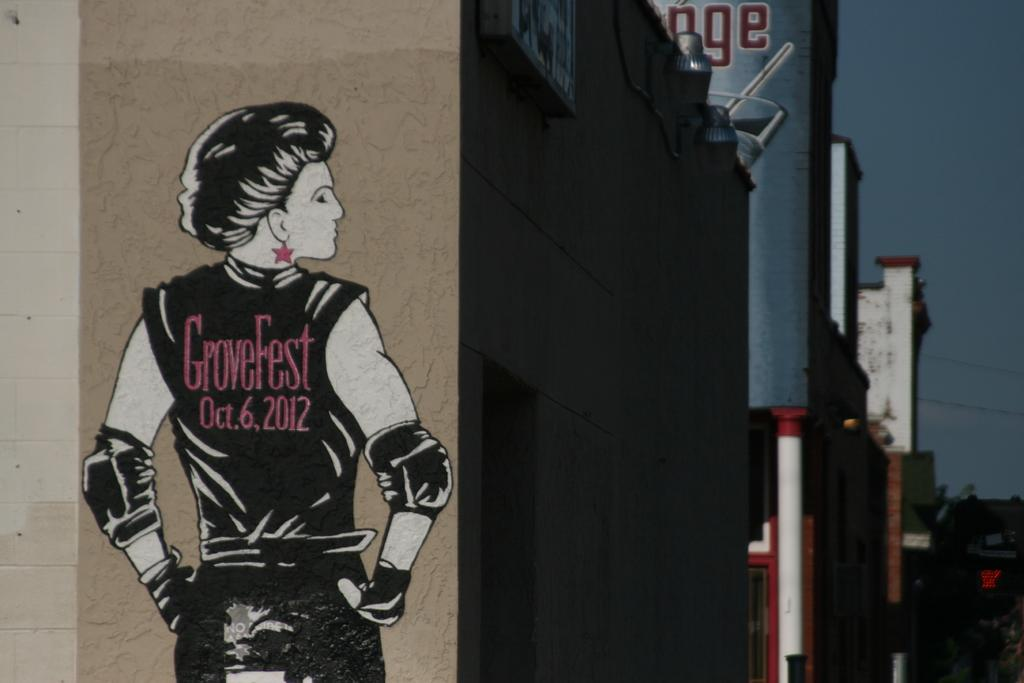What is the color of the building wall in the image? The building wall in the image is brown. What is depicted on the building wall? There is a drawing made on the building wall. What can be seen in the background of the image? There are other buildings visible in the background of the image. How many dimes does the grandfather have in the image? There is no grandfather or dimes present in the image. 